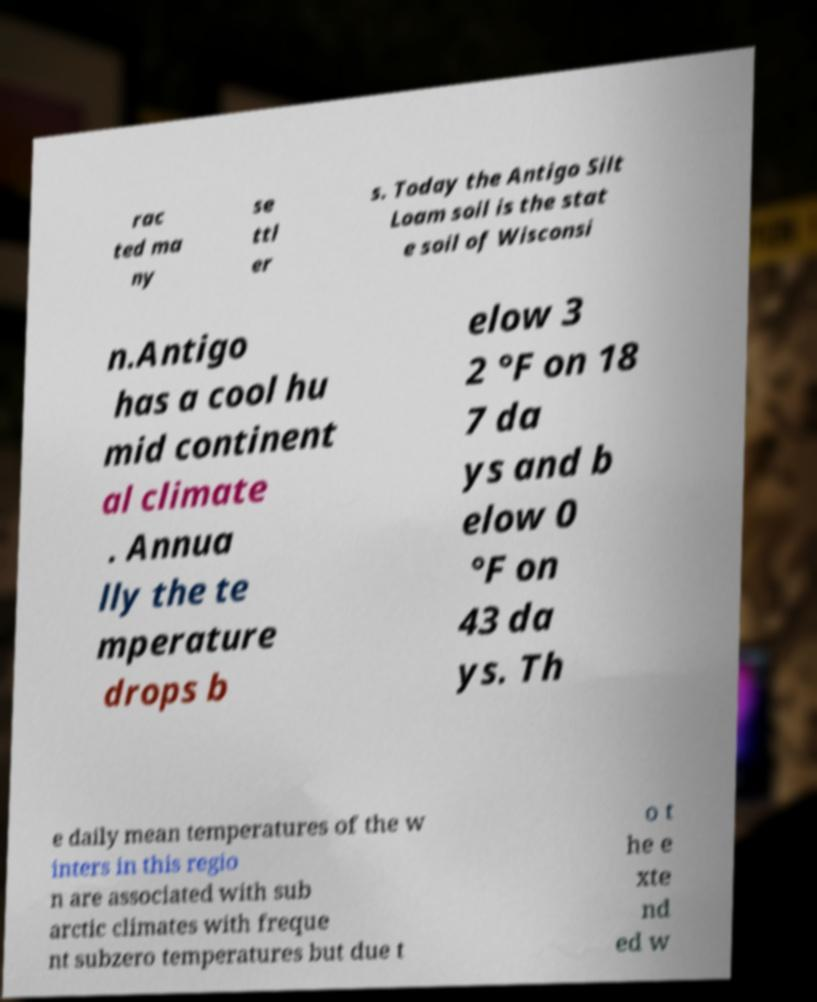What messages or text are displayed in this image? I need them in a readable, typed format. rac ted ma ny se ttl er s. Today the Antigo Silt Loam soil is the stat e soil of Wisconsi n.Antigo has a cool hu mid continent al climate . Annua lly the te mperature drops b elow 3 2 °F on 18 7 da ys and b elow 0 °F on 43 da ys. Th e daily mean temperatures of the w inters in this regio n are associated with sub arctic climates with freque nt subzero temperatures but due t o t he e xte nd ed w 